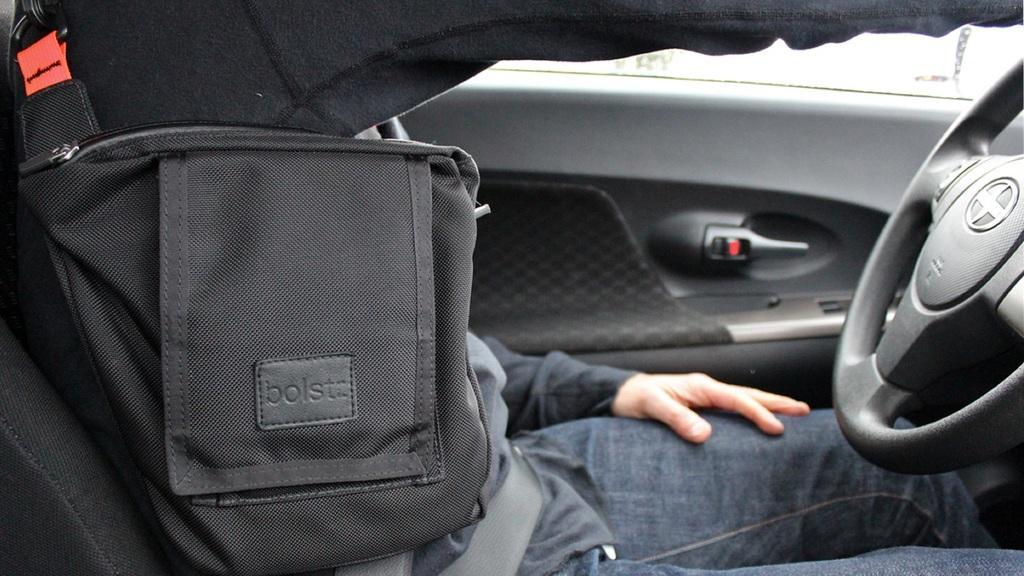In one or two sentences, can you explain what this image depicts? The image is taken in the car. On the left the man who is wearing a seatbelt is sitting in the car. 